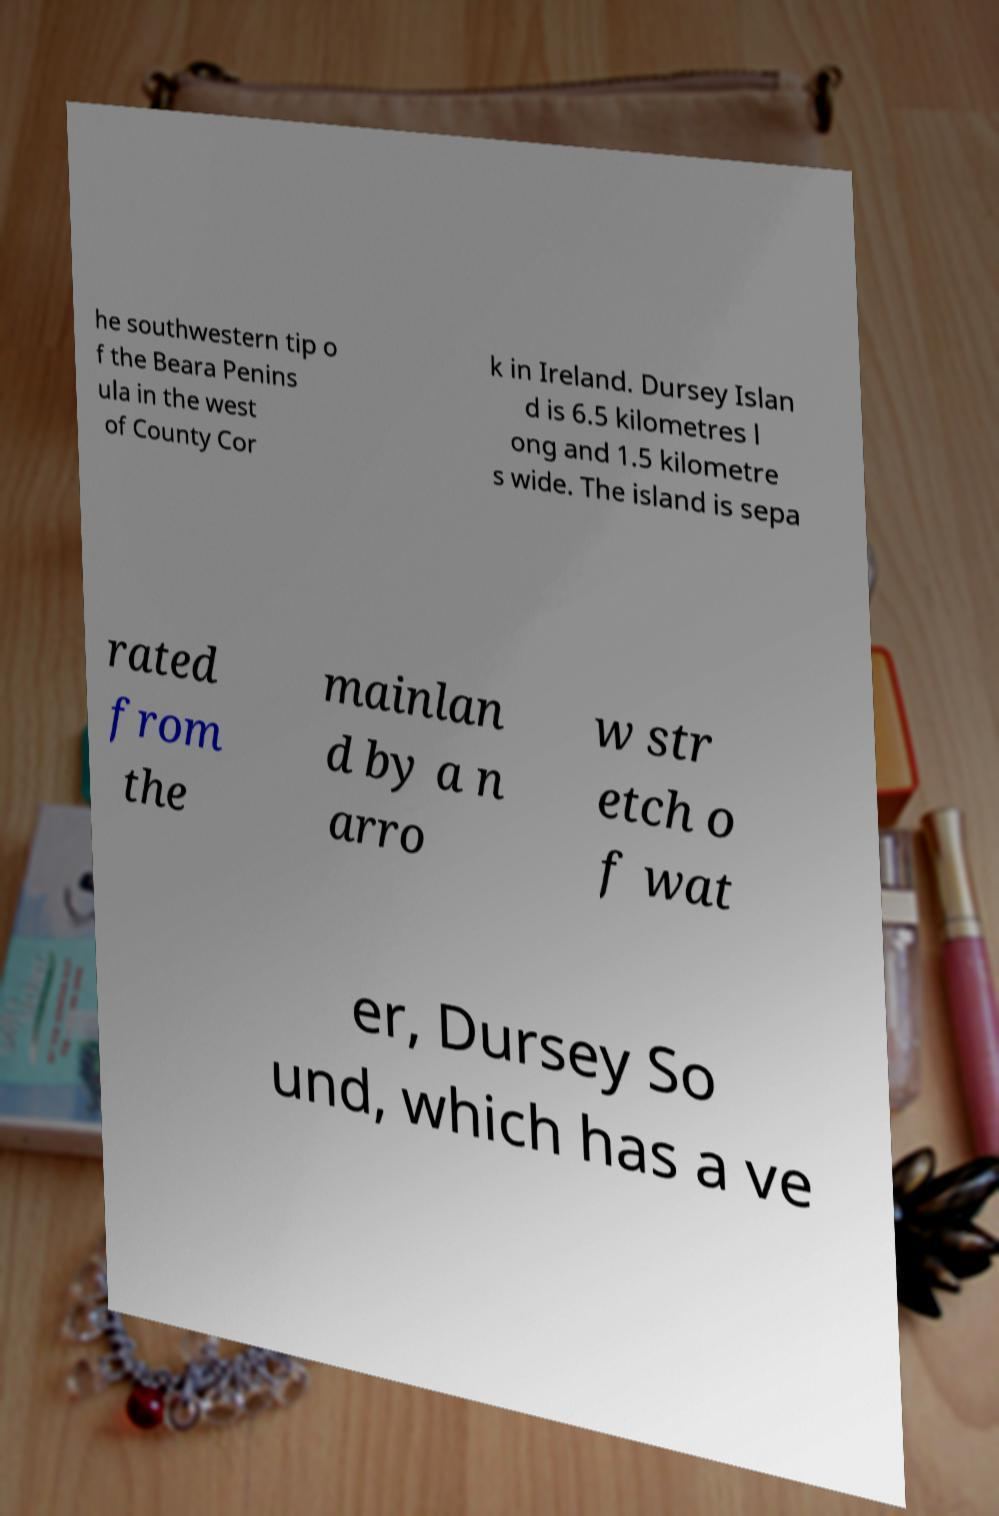Can you read and provide the text displayed in the image?This photo seems to have some interesting text. Can you extract and type it out for me? he southwestern tip o f the Beara Penins ula in the west of County Cor k in Ireland. Dursey Islan d is 6.5 kilometres l ong and 1.5 kilometre s wide. The island is sepa rated from the mainlan d by a n arro w str etch o f wat er, Dursey So und, which has a ve 